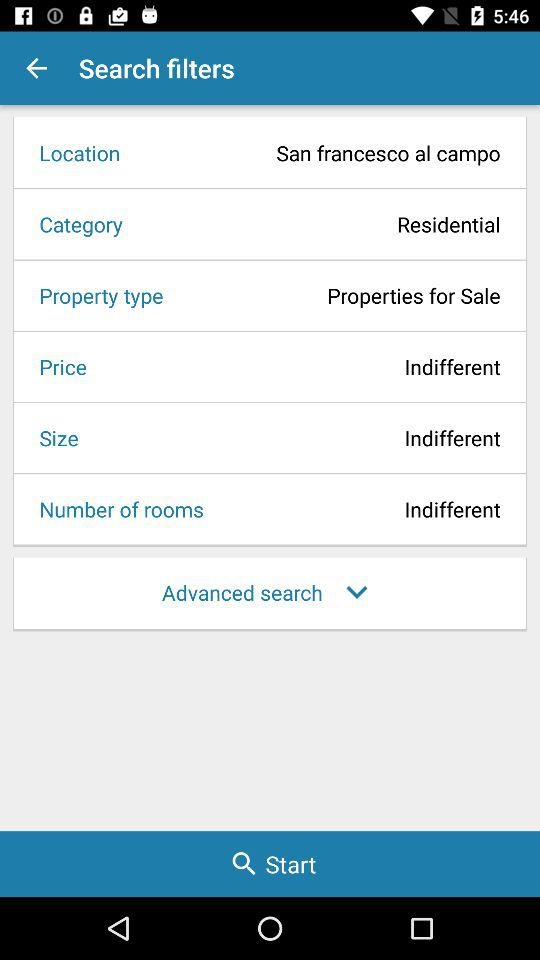What is the category of property? The category of property is residential. 